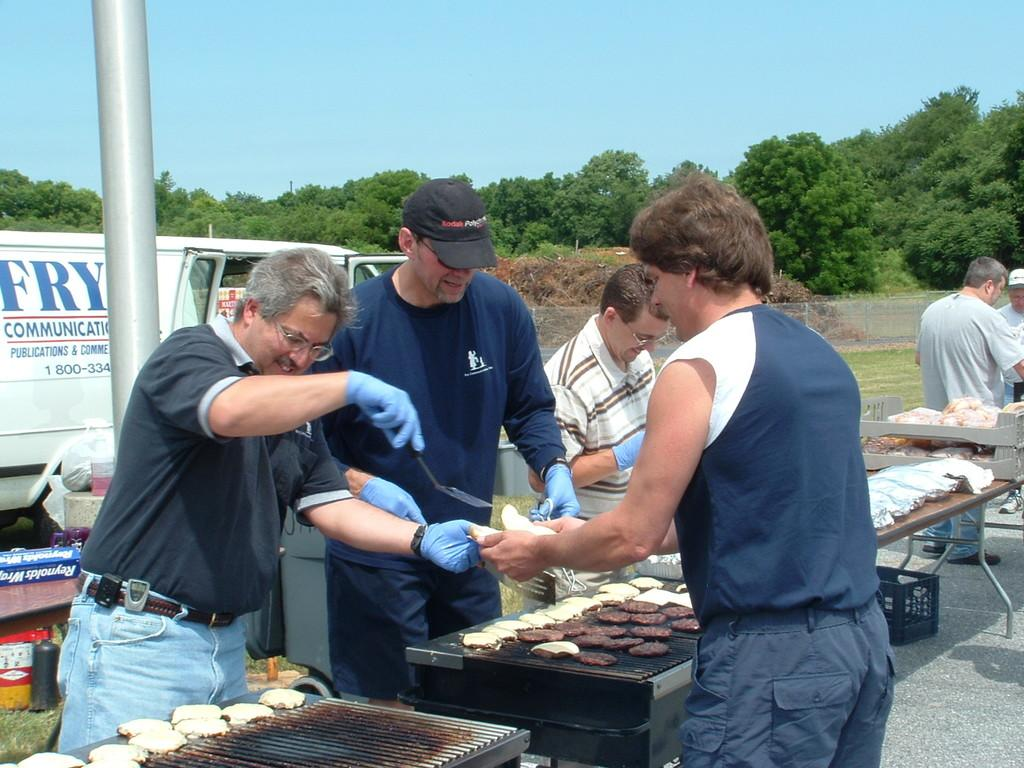<image>
Describe the image concisely. men serving food in front of a van that says 'fry communication' on it 